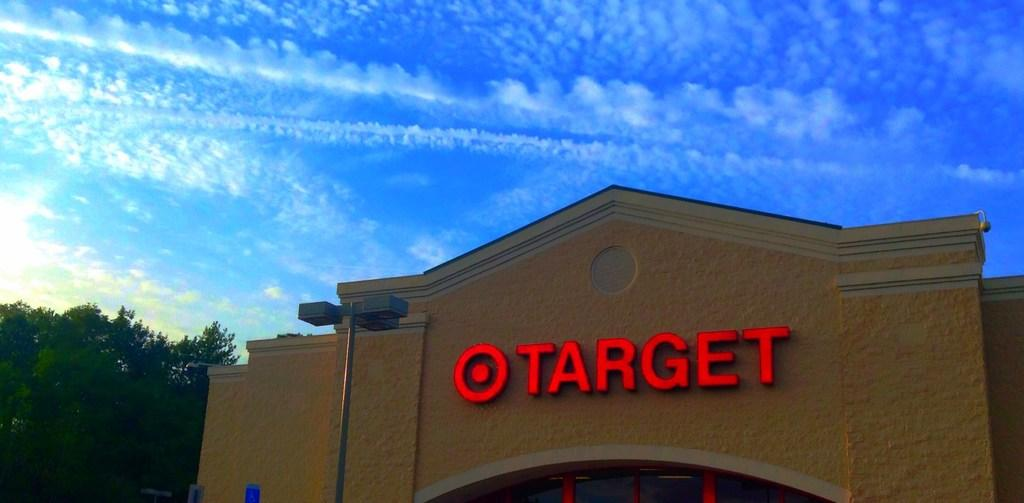What type of structure is present in the image? There is a building with windows in the image. What else can be seen in the image besides the building? There are lights on a pole and a group of trees visible in the background of the image. What is the condition of the sky in the image? The sky is visible in the image and appears cloudy. What type of lettuce is being used as a scarf by the building in the image? There is no lettuce or scarf present in the image; it features a building with windows, lights on a pole, trees in the background, and a cloudy sky. 